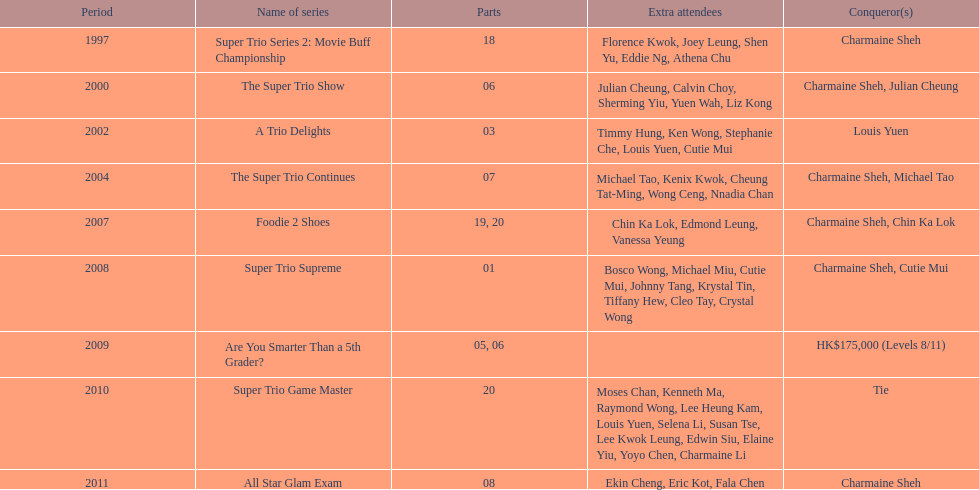How many episodes was charmaine sheh on in the variety show super trio 2: movie buff champions 18. 